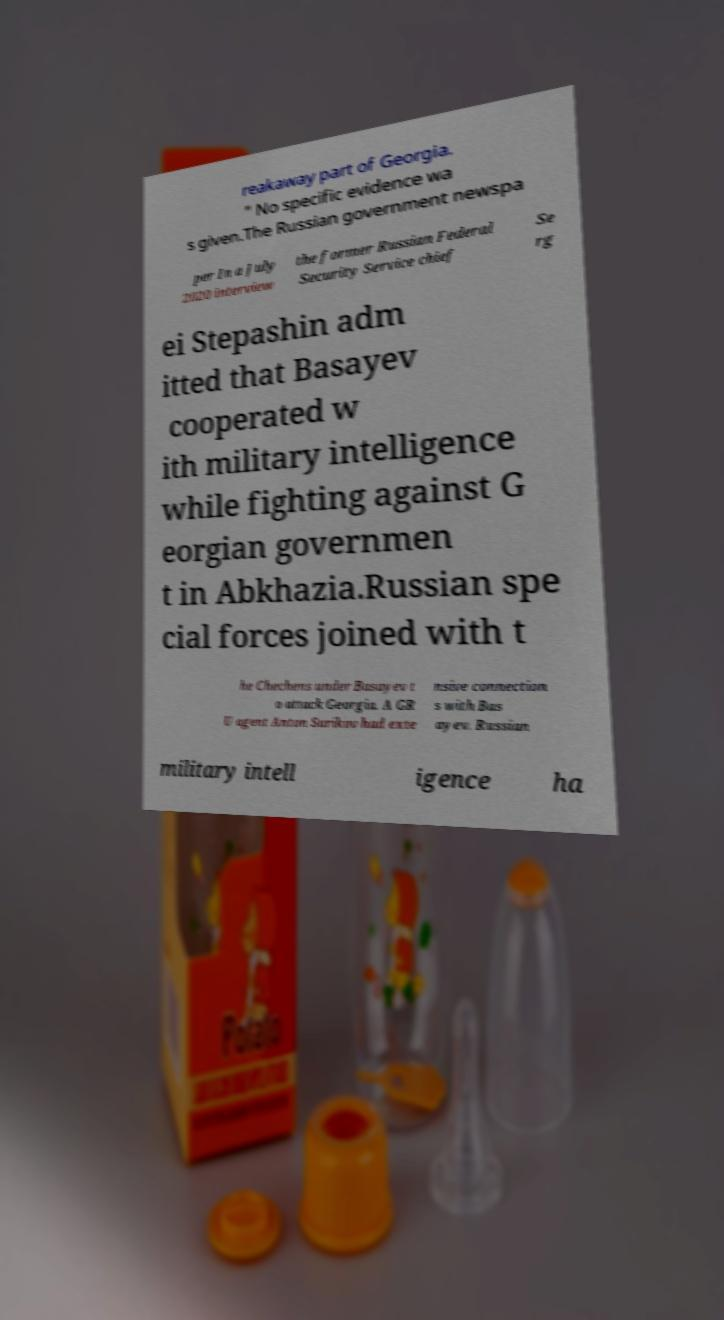Please identify and transcribe the text found in this image. reakaway part of Georgia. " No specific evidence wa s given.The Russian government newspa per In a July 2020 interview the former Russian Federal Security Service chief Se rg ei Stepashin adm itted that Basayev cooperated w ith military intelligence while fighting against G eorgian governmen t in Abkhazia.Russian spe cial forces joined with t he Chechens under Basayev t o attack Georgia. A GR U agent Anton Surikov had exte nsive connection s with Bas ayev. Russian military intell igence ha 